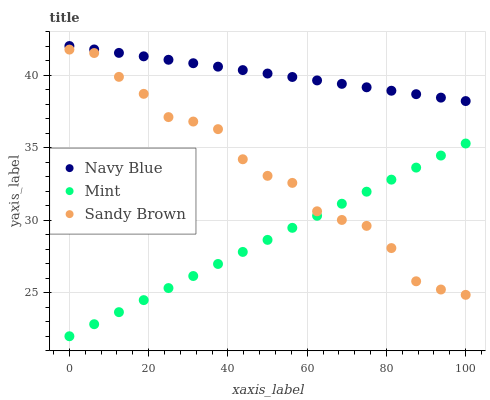Does Mint have the minimum area under the curve?
Answer yes or no. Yes. Does Navy Blue have the maximum area under the curve?
Answer yes or no. Yes. Does Sandy Brown have the minimum area under the curve?
Answer yes or no. No. Does Sandy Brown have the maximum area under the curve?
Answer yes or no. No. Is Mint the smoothest?
Answer yes or no. Yes. Is Sandy Brown the roughest?
Answer yes or no. Yes. Is Sandy Brown the smoothest?
Answer yes or no. No. Is Mint the roughest?
Answer yes or no. No. Does Mint have the lowest value?
Answer yes or no. Yes. Does Sandy Brown have the lowest value?
Answer yes or no. No. Does Navy Blue have the highest value?
Answer yes or no. Yes. Does Sandy Brown have the highest value?
Answer yes or no. No. Is Mint less than Navy Blue?
Answer yes or no. Yes. Is Navy Blue greater than Sandy Brown?
Answer yes or no. Yes. Does Mint intersect Sandy Brown?
Answer yes or no. Yes. Is Mint less than Sandy Brown?
Answer yes or no. No. Is Mint greater than Sandy Brown?
Answer yes or no. No. Does Mint intersect Navy Blue?
Answer yes or no. No. 